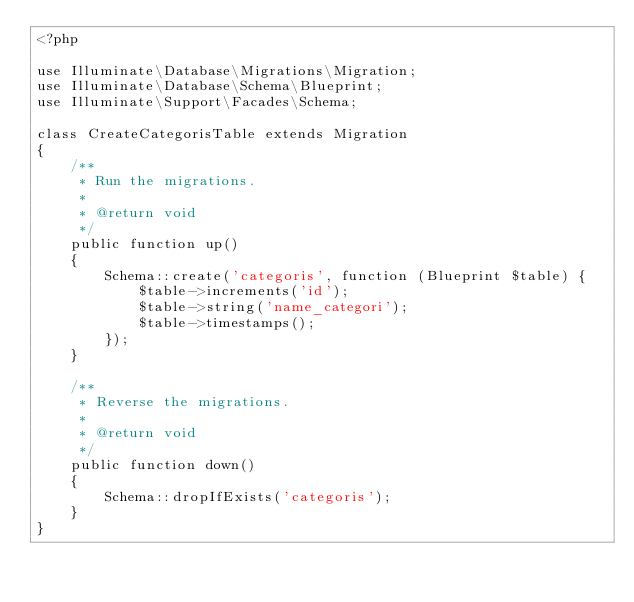<code> <loc_0><loc_0><loc_500><loc_500><_PHP_><?php

use Illuminate\Database\Migrations\Migration;
use Illuminate\Database\Schema\Blueprint;
use Illuminate\Support\Facades\Schema;

class CreateCategorisTable extends Migration
{
    /**
     * Run the migrations.
     *
     * @return void
     */
    public function up()
    {
        Schema::create('categoris', function (Blueprint $table) {
            $table->increments('id');
            $table->string('name_categori');
            $table->timestamps();
        });
    }

    /**
     * Reverse the migrations.
     *
     * @return void
     */
    public function down()
    {
        Schema::dropIfExists('categoris');
    }
}
</code> 